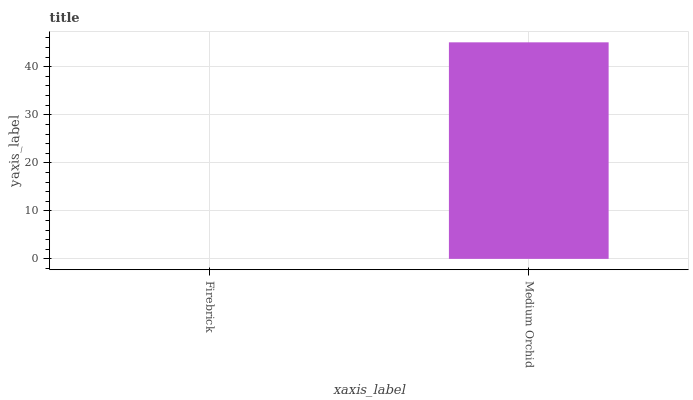Is Firebrick the minimum?
Answer yes or no. Yes. Is Medium Orchid the maximum?
Answer yes or no. Yes. Is Medium Orchid the minimum?
Answer yes or no. No. Is Medium Orchid greater than Firebrick?
Answer yes or no. Yes. Is Firebrick less than Medium Orchid?
Answer yes or no. Yes. Is Firebrick greater than Medium Orchid?
Answer yes or no. No. Is Medium Orchid less than Firebrick?
Answer yes or no. No. Is Medium Orchid the high median?
Answer yes or no. Yes. Is Firebrick the low median?
Answer yes or no. Yes. Is Firebrick the high median?
Answer yes or no. No. Is Medium Orchid the low median?
Answer yes or no. No. 